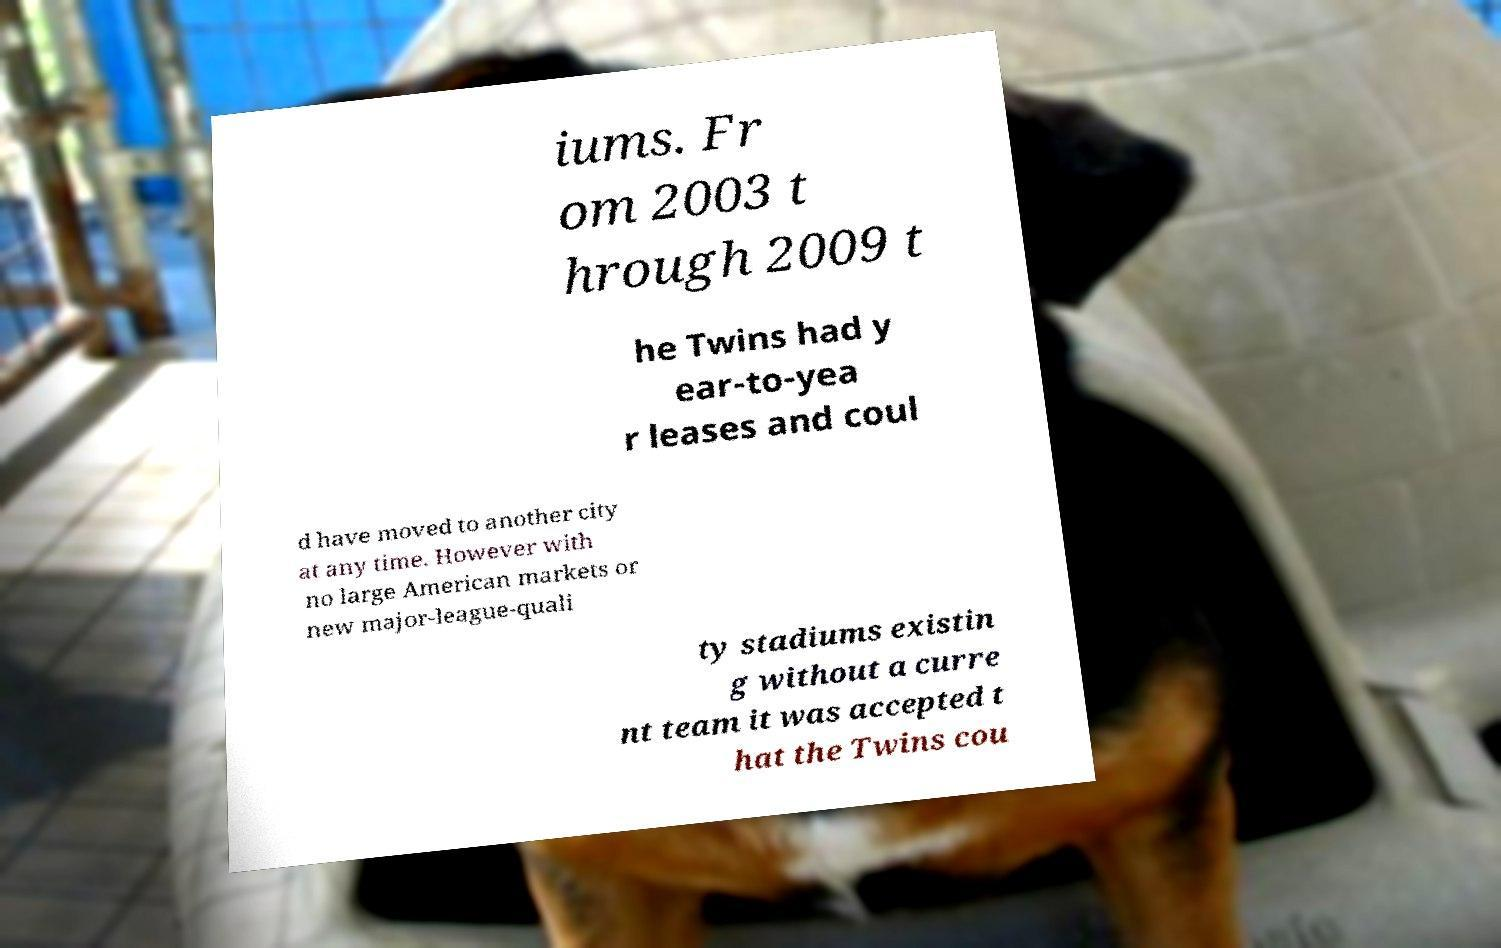What messages or text are displayed in this image? I need them in a readable, typed format. iums. Fr om 2003 t hrough 2009 t he Twins had y ear-to-yea r leases and coul d have moved to another city at any time. However with no large American markets or new major-league-quali ty stadiums existin g without a curre nt team it was accepted t hat the Twins cou 